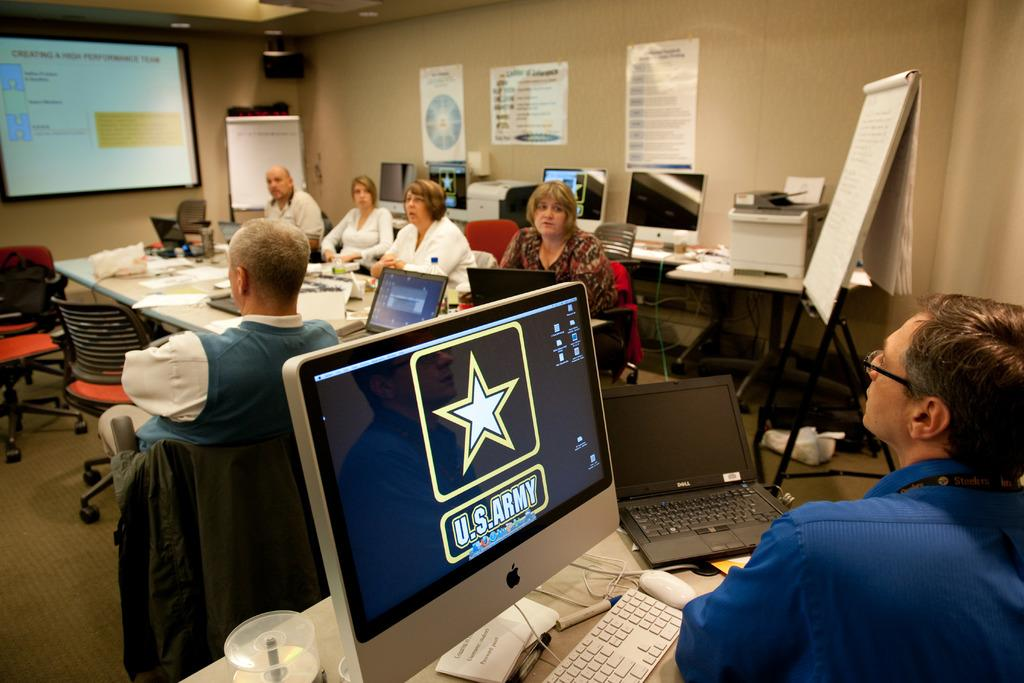<image>
Give a short and clear explanation of the subsequent image. A group of people are gathered in a room for a meeting, with the US Army logo up on a apple computer. 